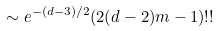Convert formula to latex. <formula><loc_0><loc_0><loc_500><loc_500>\sim e ^ { - ( d - 3 ) / 2 } ( 2 ( d - 2 ) m - 1 ) ! !</formula> 